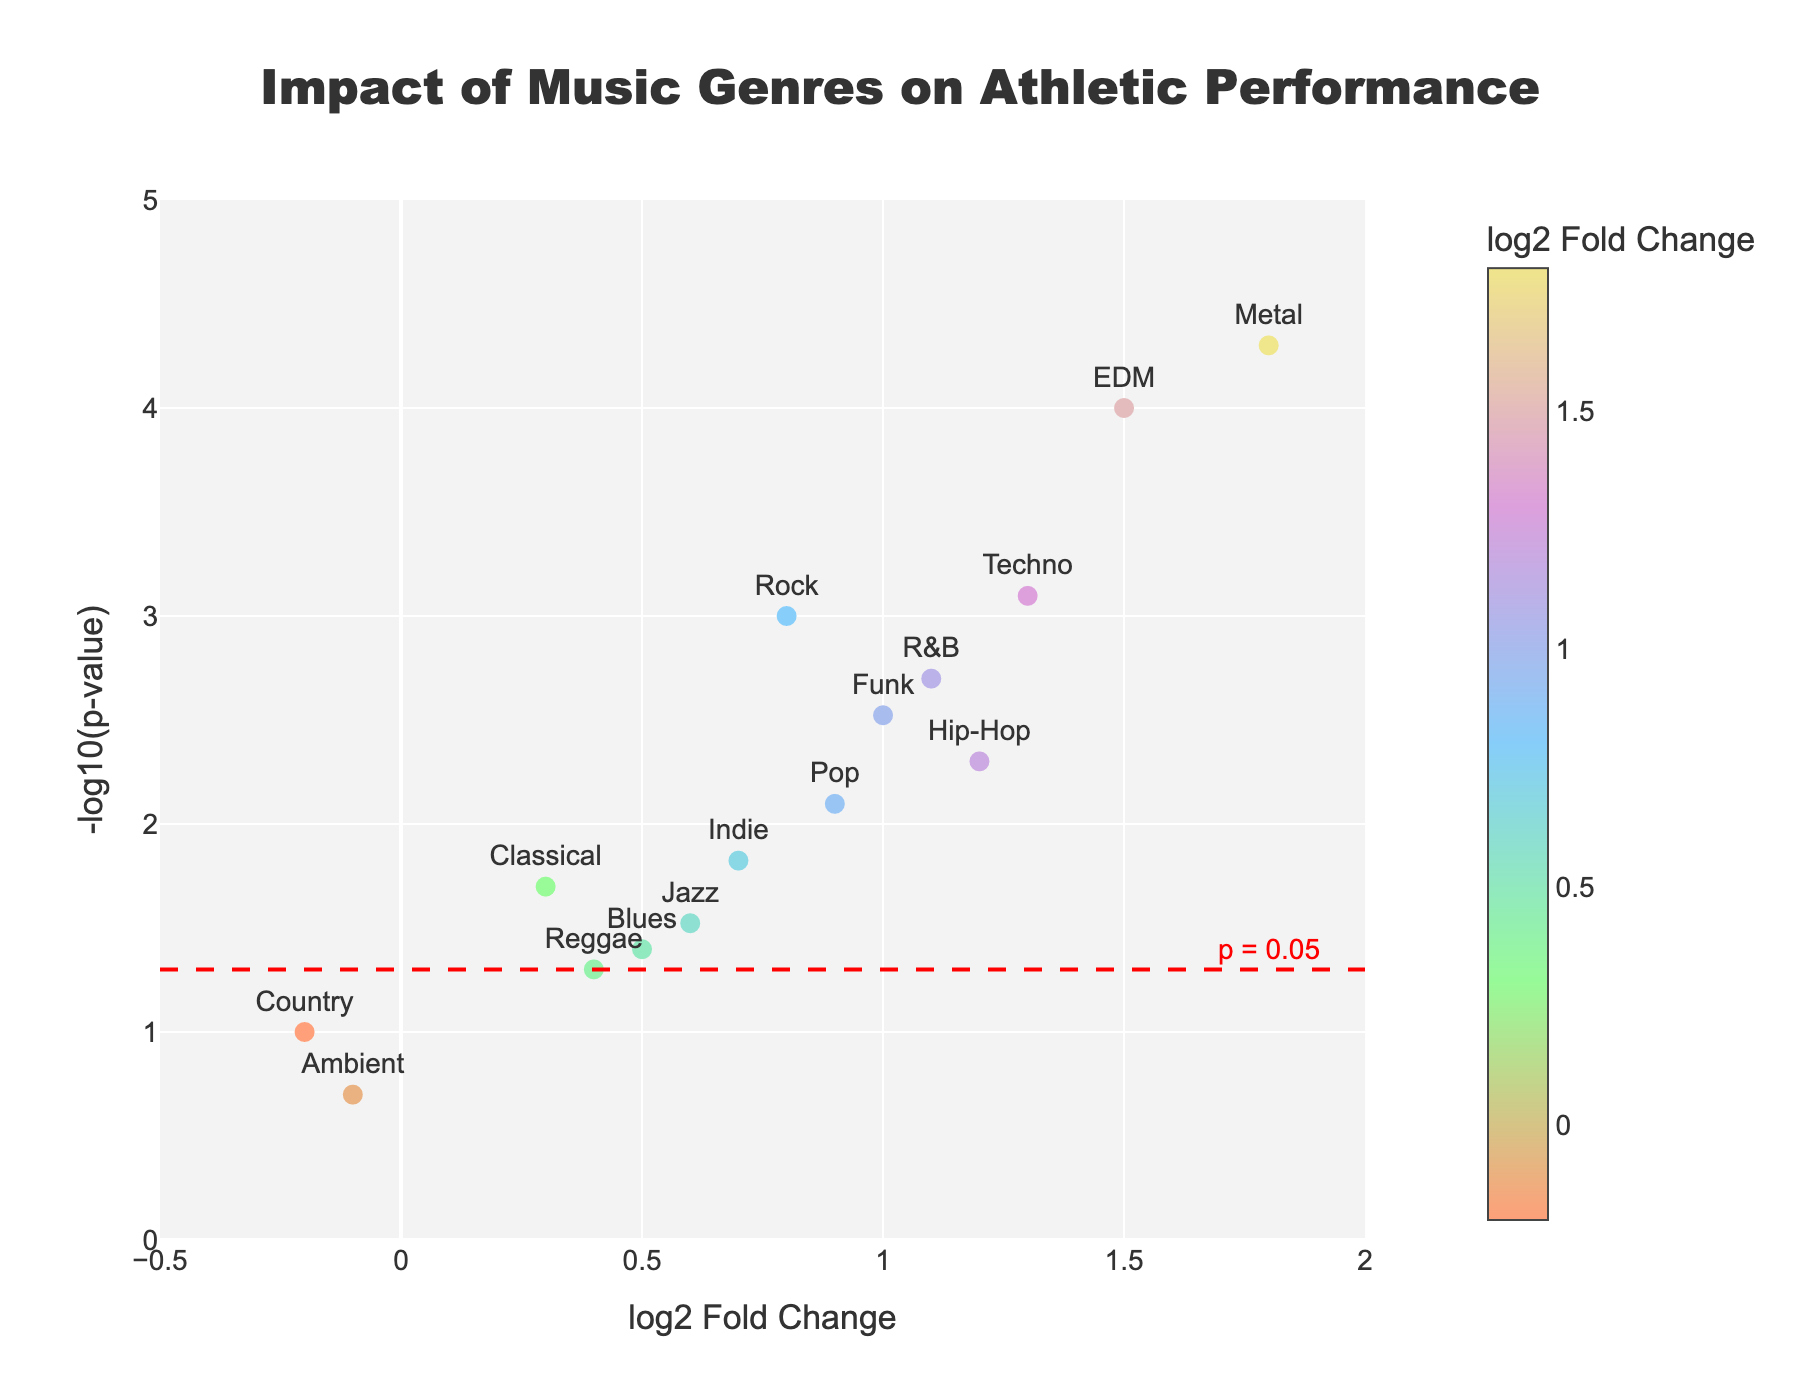How many genres of music are represented in the plot? The plot shows data points labeled with different genres. By counting the number of unique labels, we can determine the number of genres.
Answer: 15 Which music genre has the highest -log10(p-value) and what is its log2 fold change? The highest -log10(p-value) corresponds to the highest point on the vertical axis. By identifying this point, which in the plot is Metal, check its log2 fold change value on the horizontal axis.
Answer: Metal, 1.8 Which genres have a log2 fold change greater than 1? Genres with log2 fold change values greater than 1 are those whose points appear to the right of the value 1 on the horizontal axis.
Answer: Hip-Hop, EDM, R&B, Metal, Techno What can you say about the impact of Country music on athletic performance compared to other genres? Locate Country music point on the plot and compare its log2 fold change and -log10(p-value) to other genres. Country has a negative log2 fold change and a high p-value, indicating a potentially negligible or negative effect on performance.
Answer: Country music has a low and not statistically significant impact If Hip-Hop, EDM, and Techno points represent some of the highest log2 fold changes, which of them has the smallest p-value? Compare the vertical positions of the points labeled Hip-Hop, EDM, and Techno, and identify the one closest to the top.
Answer: EDM What does the red dashed line represent, and which genres fall below this line? The red dashed line represents the significance threshold (p=0.05/-log10(p=0.05) ~1.3). Points below this line have a p-value > 0.05.
Answer: Country, Reggae, Blues, Jazz, and Ambient Which music genre has the smallest -log10(p-value), indicating the least statistical significance? The smallest -log10(p-value) is the lowest point on the vertical axis. Identify the corresponding genre label.
Answer: Ambient Are there any genres with a negative log2 fold change? If so, name them. Points with negative log2 fold change appear to the left of the zero value on the horizontal axis.
Answer: Country, Ambient 